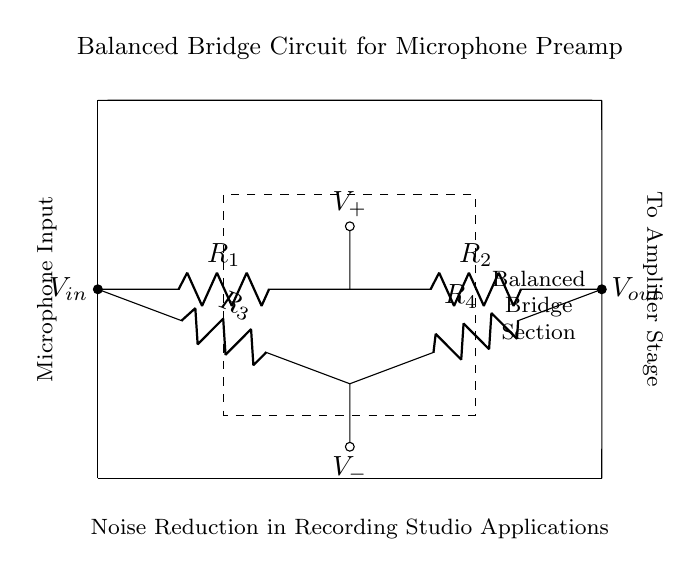What is the total number of resistors in the circuit? The diagram shows a balanced bridge circuit with four resistors labeled R1, R2, R3, and R4, all connected in a specific arrangement. Counting these, there are four resistors in total.
Answer: four What is the symbol for the microphone input? In the diagram, the microphone input is indicated by a label showing "Microphone Input" on the left side. This denotes where the microphone connects to the circuit.
Answer: Microphone Input What does V-out represent in the circuit? V-out is labeled on the right side of the diagram and represents the output voltage from the balanced bridge circuit to the next stage of the amplifier.
Answer: output voltage What voltage is represented at the junction between R2 and R4? The voltage at this junction is labeled as V+, which indicates the positive reference voltage from the microphonic signal processed by the resistors R2 and R4.
Answer: V+ What is the purpose of the balanced bridge circuit? The balanced bridge circuit is specifically designed for noise reduction in microphone preamps, as mentioned in the description below the circuit. The purpose is to minimize noise that could interfere with the audio signal.
Answer: Noise reduction What configuration do resistors R1 and R3 share in the circuit? The resistors R1 and R3 are arranged in parallel on one side of the bridge section. This parallel arrangement influences the balance and functionality of the circuit for effective sound signal processing.
Answer: Parallel How can you identify the balanced nature of this bridge circuit? The balanced nature is indicated by the symmetry in the arrangement of resistors R1, R2, R3, and R4, with equal impedance paths from the input to the output. This is a characteristic feature of a balanced bridge circuit, aimed at reducing noise.
Answer: Symmetry 